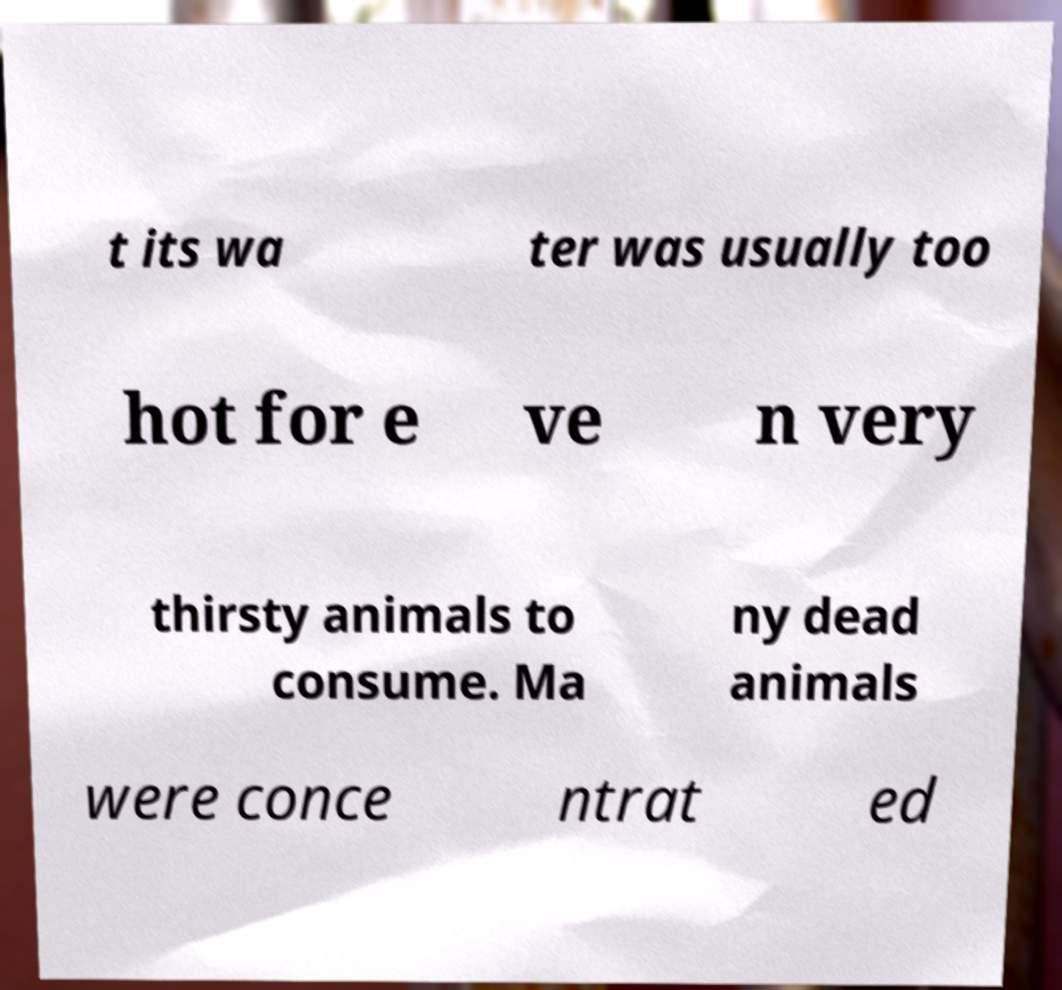Please read and relay the text visible in this image. What does it say? t its wa ter was usually too hot for e ve n very thirsty animals to consume. Ma ny dead animals were conce ntrat ed 